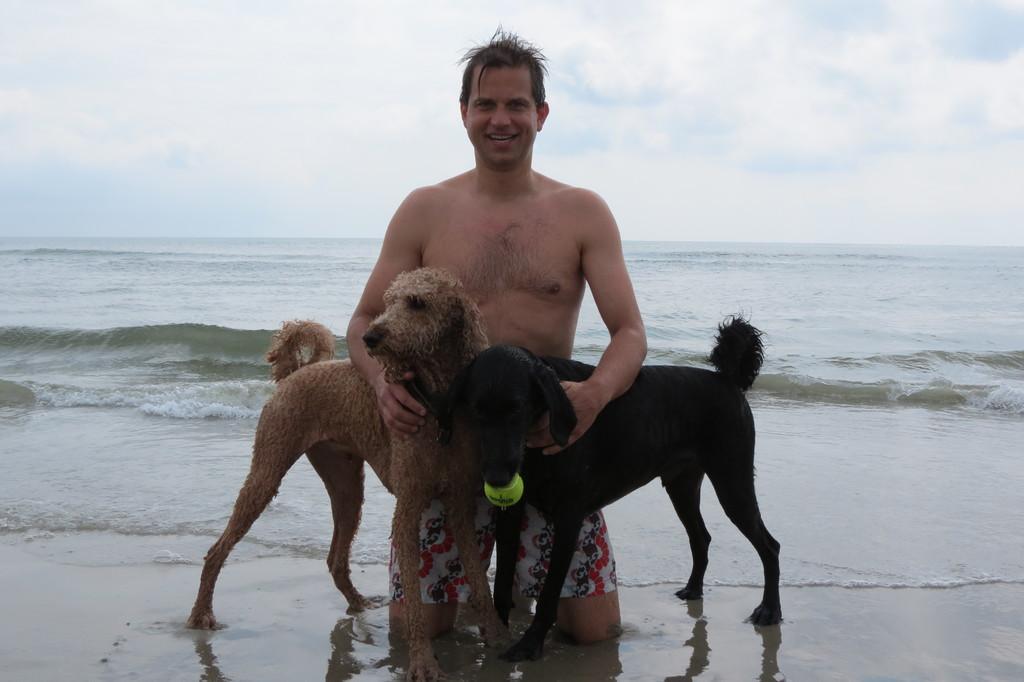Could you give a brief overview of what you see in this image? In this picture we can see a man and two dogs, in the background there is water, we can see the sky at the top of the picture. 